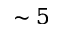Convert formula to latex. <formula><loc_0><loc_0><loc_500><loc_500>\sim 5</formula> 